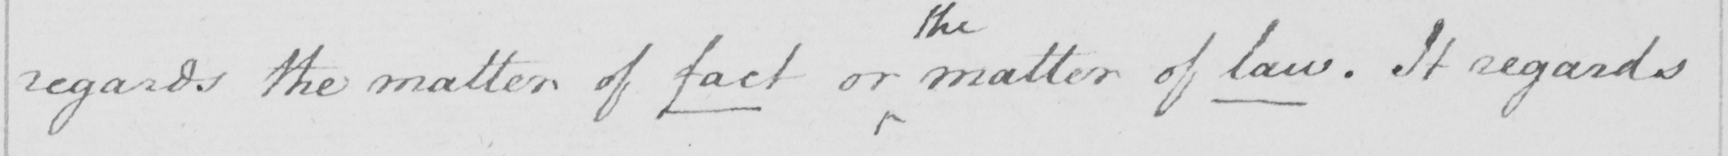What text is written in this handwritten line? regards the matter of fact or the matter of law. It regards 